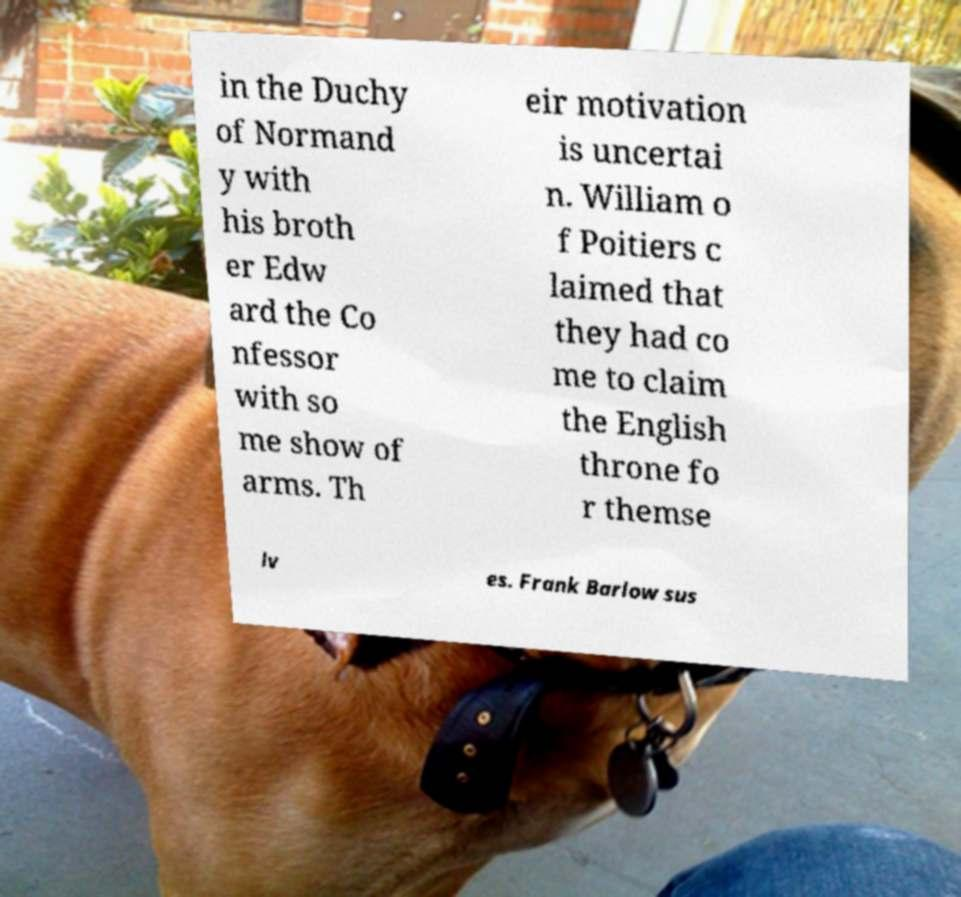Please read and relay the text visible in this image. What does it say? in the Duchy of Normand y with his broth er Edw ard the Co nfessor with so me show of arms. Th eir motivation is uncertai n. William o f Poitiers c laimed that they had co me to claim the English throne fo r themse lv es. Frank Barlow sus 